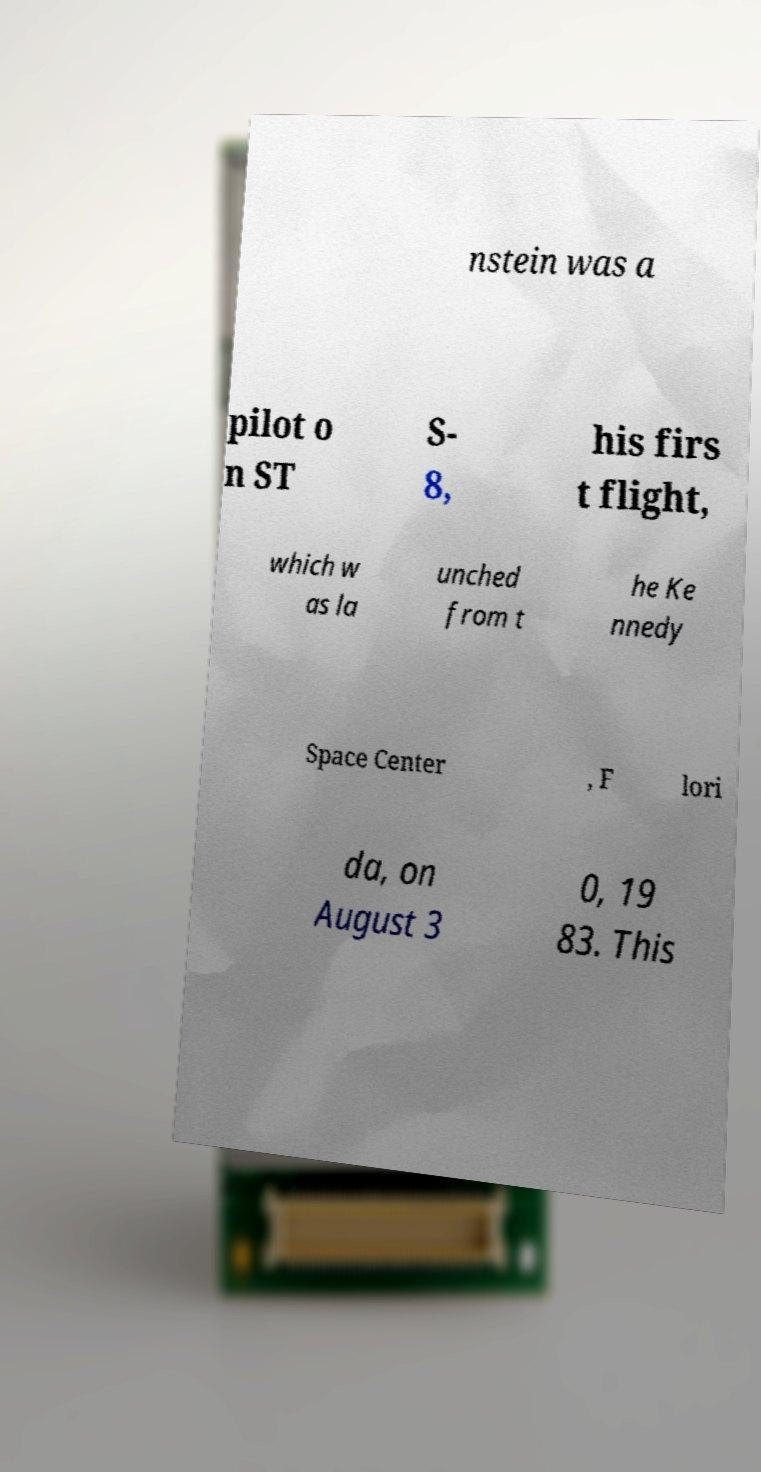Could you assist in decoding the text presented in this image and type it out clearly? nstein was a pilot o n ST S- 8, his firs t flight, which w as la unched from t he Ke nnedy Space Center , F lori da, on August 3 0, 19 83. This 